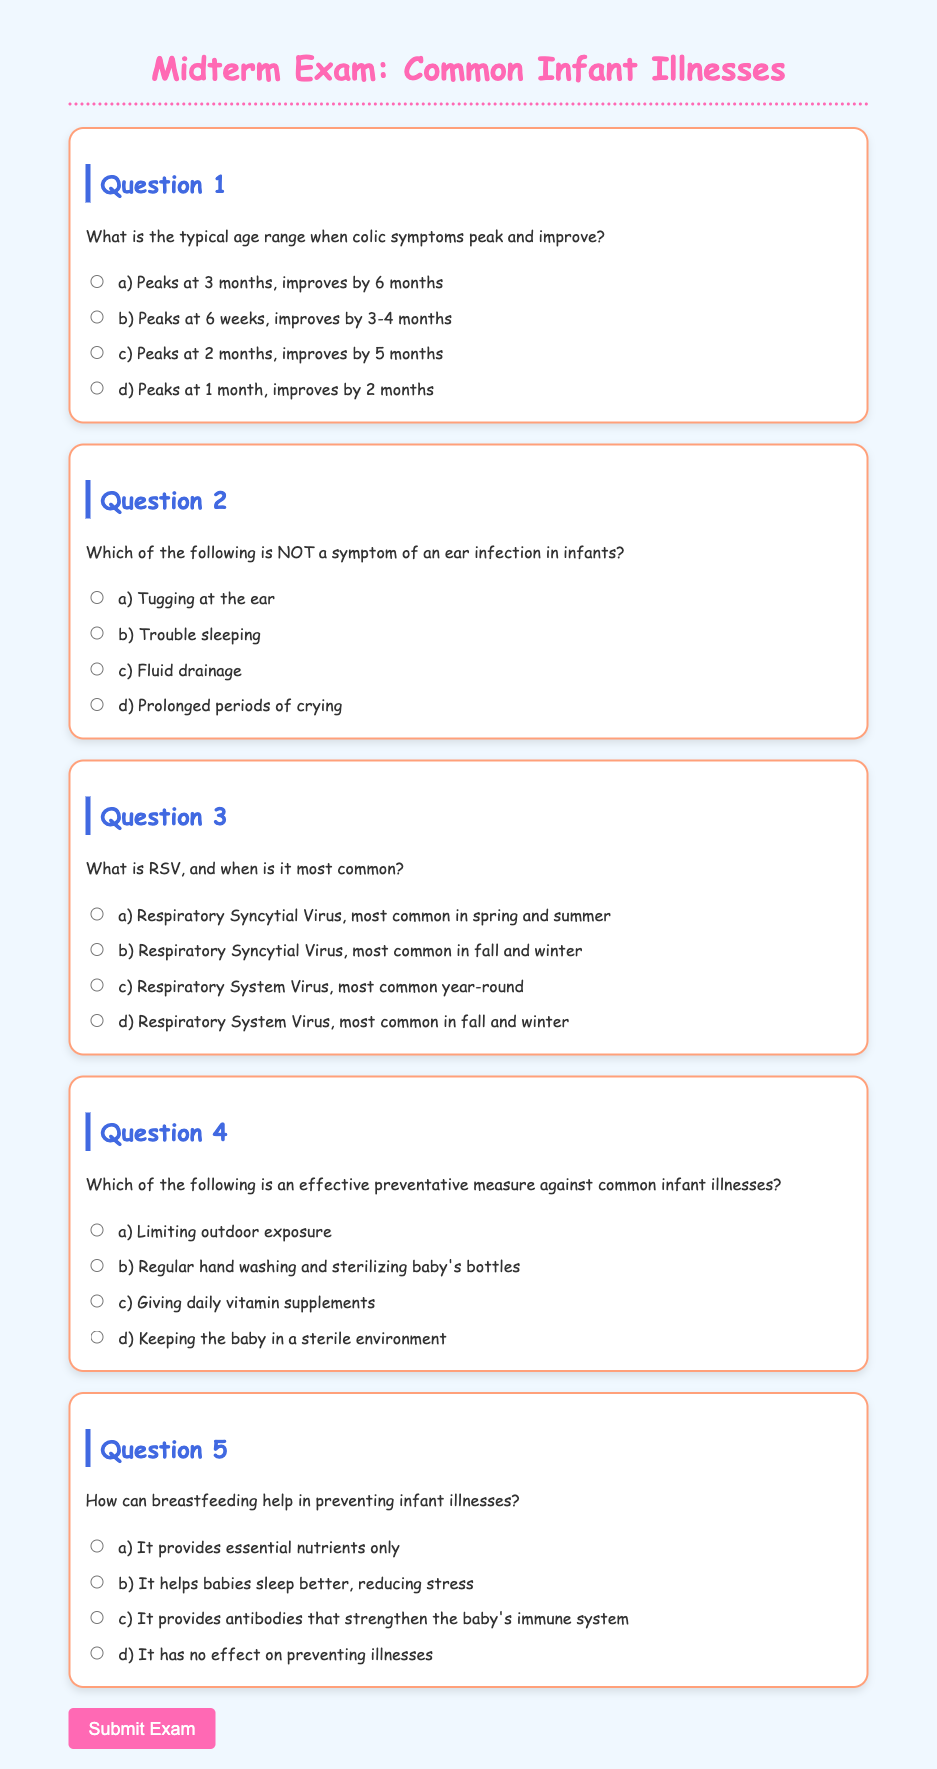What is the title of the document? The title of the document is specified in the head section of the HTML, which is "Midterm Exam: Common Infant Illnesses".
Answer: Midterm Exam: Common Infant Illnesses What age range does colic symptoms peak and improve? The document states that colic peaks at 3 months and improves by 6 months.
Answer: 3 months, 6 months What is RSV? The document defines RSV as Respiratory Syncytial Virus.
Answer: Respiratory Syncytial Virus Which preventive measure involves hand washing? The document mentions that regular hand washing and sterilizing baby's bottles is an effective preventive measure against common infant illnesses.
Answer: Regular hand washing and sterilizing baby's bottles In which months is RSV most common? According to the document, RSV is most common in fall and winter.
Answer: Fall and winter Which option describes breastfeeding's effect on preventing illnesses? The document indicates that breastfeeding provides antibodies that strengthen the baby's immune system.
Answer: Provides antibodies that strengthen the baby's immune system How many questions are included in the exam? By counting the question sections in the document, we find that there are five questions in total.
Answer: Five Which color is used for the header in the document? The color of the header, as defined in the CSS styles, is #ff69b4.
Answer: #ff69b4 What is one symptom of an ear infection in infants listed in the document? The document lists "tugging at the ear" as a symptom of an ear infection in infants.
Answer: Tugging at the ear 